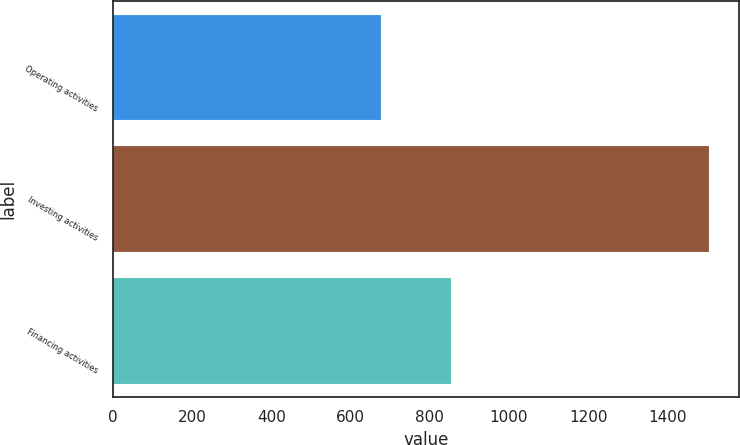<chart> <loc_0><loc_0><loc_500><loc_500><bar_chart><fcel>Operating activities<fcel>Investing activities<fcel>Financing activities<nl><fcel>677.9<fcel>1505.5<fcel>853.9<nl></chart> 